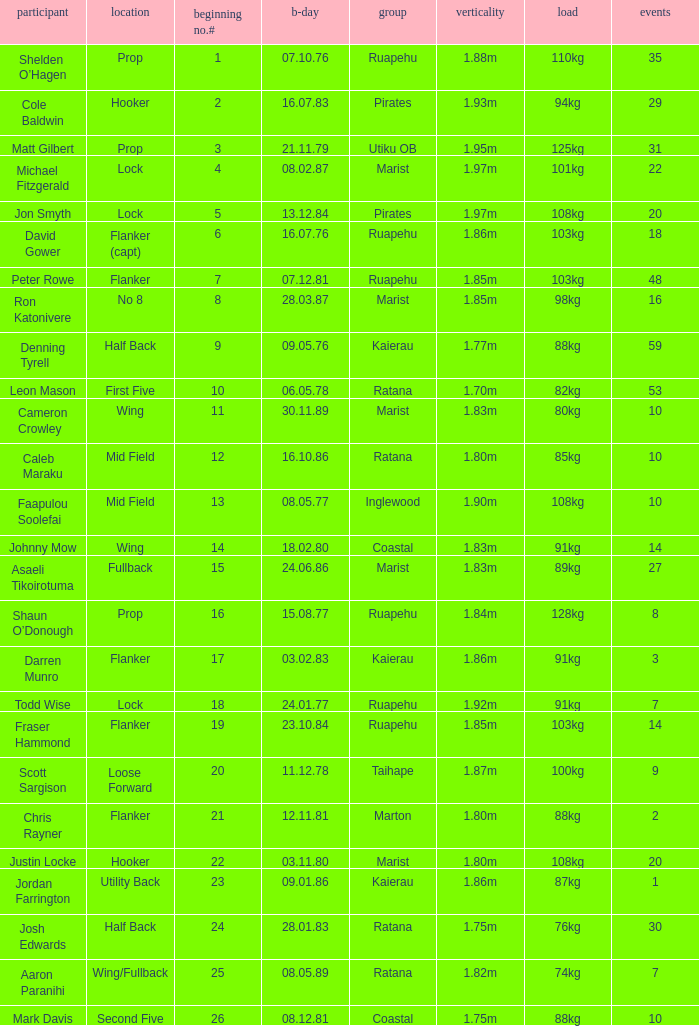Which player weighs 76kg? Josh Edwards. 